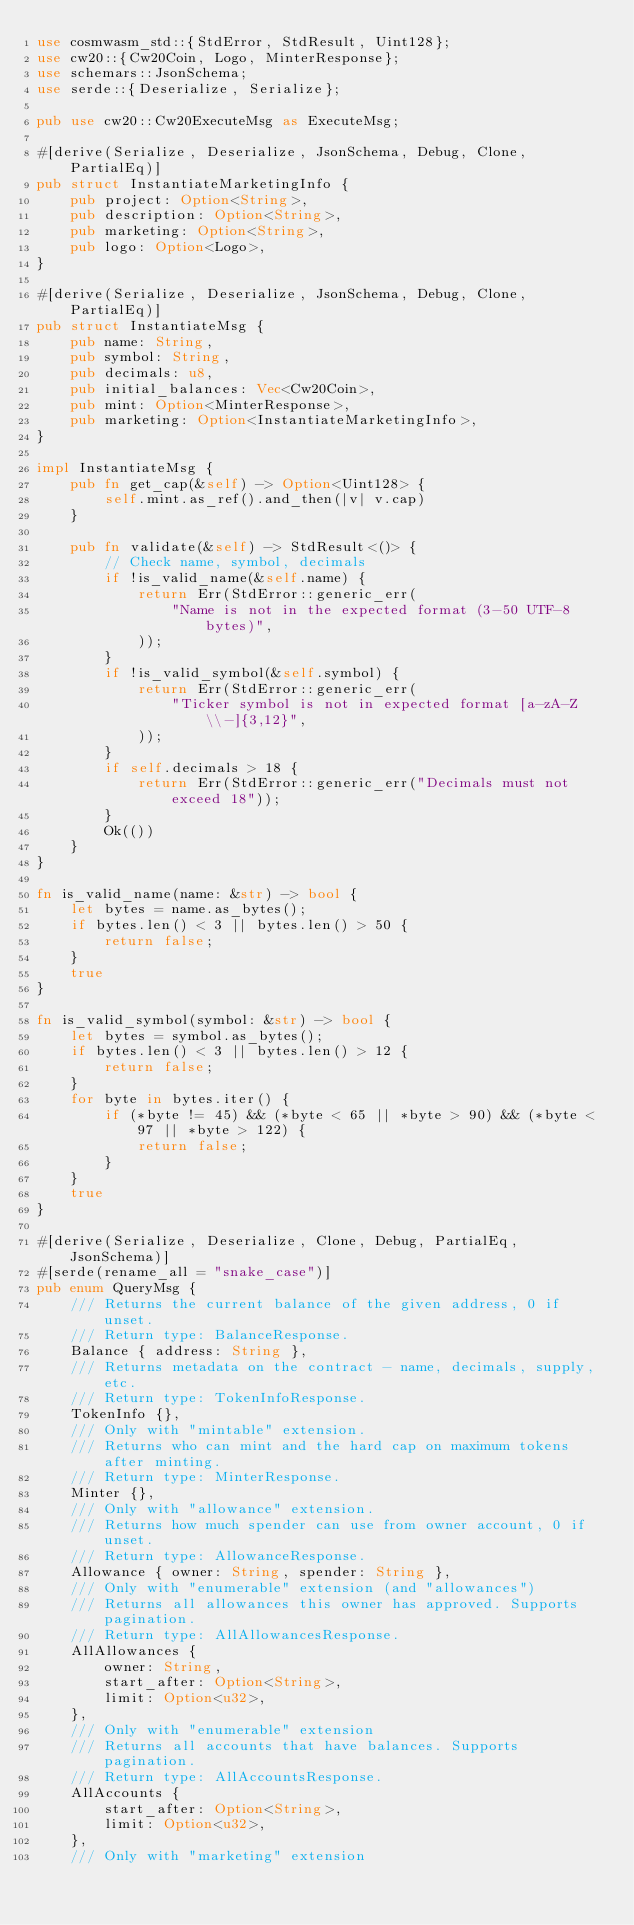<code> <loc_0><loc_0><loc_500><loc_500><_Rust_>use cosmwasm_std::{StdError, StdResult, Uint128};
use cw20::{Cw20Coin, Logo, MinterResponse};
use schemars::JsonSchema;
use serde::{Deserialize, Serialize};

pub use cw20::Cw20ExecuteMsg as ExecuteMsg;

#[derive(Serialize, Deserialize, JsonSchema, Debug, Clone, PartialEq)]
pub struct InstantiateMarketingInfo {
    pub project: Option<String>,
    pub description: Option<String>,
    pub marketing: Option<String>,
    pub logo: Option<Logo>,
}

#[derive(Serialize, Deserialize, JsonSchema, Debug, Clone, PartialEq)]
pub struct InstantiateMsg {
    pub name: String,
    pub symbol: String,
    pub decimals: u8,
    pub initial_balances: Vec<Cw20Coin>,
    pub mint: Option<MinterResponse>,
    pub marketing: Option<InstantiateMarketingInfo>,
}

impl InstantiateMsg {
    pub fn get_cap(&self) -> Option<Uint128> {
        self.mint.as_ref().and_then(|v| v.cap)
    }

    pub fn validate(&self) -> StdResult<()> {
        // Check name, symbol, decimals
        if !is_valid_name(&self.name) {
            return Err(StdError::generic_err(
                "Name is not in the expected format (3-50 UTF-8 bytes)",
            ));
        }
        if !is_valid_symbol(&self.symbol) {
            return Err(StdError::generic_err(
                "Ticker symbol is not in expected format [a-zA-Z\\-]{3,12}",
            ));
        }
        if self.decimals > 18 {
            return Err(StdError::generic_err("Decimals must not exceed 18"));
        }
        Ok(())
    }
}

fn is_valid_name(name: &str) -> bool {
    let bytes = name.as_bytes();
    if bytes.len() < 3 || bytes.len() > 50 {
        return false;
    }
    true
}

fn is_valid_symbol(symbol: &str) -> bool {
    let bytes = symbol.as_bytes();
    if bytes.len() < 3 || bytes.len() > 12 {
        return false;
    }
    for byte in bytes.iter() {
        if (*byte != 45) && (*byte < 65 || *byte > 90) && (*byte < 97 || *byte > 122) {
            return false;
        }
    }
    true
}

#[derive(Serialize, Deserialize, Clone, Debug, PartialEq, JsonSchema)]
#[serde(rename_all = "snake_case")]
pub enum QueryMsg {
    /// Returns the current balance of the given address, 0 if unset.
    /// Return type: BalanceResponse.
    Balance { address: String },
    /// Returns metadata on the contract - name, decimals, supply, etc.
    /// Return type: TokenInfoResponse.
    TokenInfo {},
    /// Only with "mintable" extension.
    /// Returns who can mint and the hard cap on maximum tokens after minting.
    /// Return type: MinterResponse.
    Minter {},
    /// Only with "allowance" extension.
    /// Returns how much spender can use from owner account, 0 if unset.
    /// Return type: AllowanceResponse.
    Allowance { owner: String, spender: String },
    /// Only with "enumerable" extension (and "allowances")
    /// Returns all allowances this owner has approved. Supports pagination.
    /// Return type: AllAllowancesResponse.
    AllAllowances {
        owner: String,
        start_after: Option<String>,
        limit: Option<u32>,
    },
    /// Only with "enumerable" extension
    /// Returns all accounts that have balances. Supports pagination.
    /// Return type: AllAccountsResponse.
    AllAccounts {
        start_after: Option<String>,
        limit: Option<u32>,
    },
    /// Only with "marketing" extension</code> 